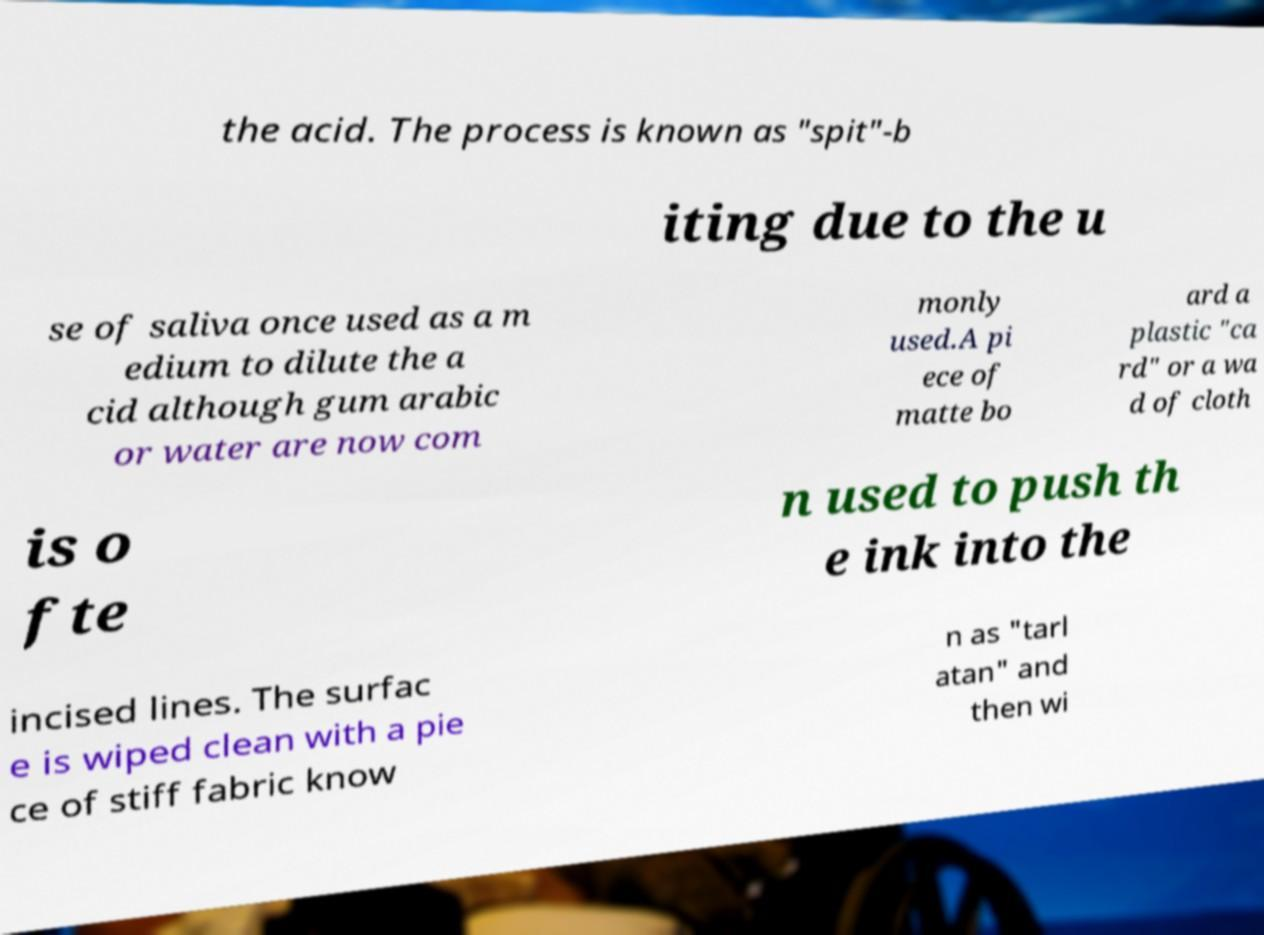Can you accurately transcribe the text from the provided image for me? the acid. The process is known as "spit"-b iting due to the u se of saliva once used as a m edium to dilute the a cid although gum arabic or water are now com monly used.A pi ece of matte bo ard a plastic "ca rd" or a wa d of cloth is o fte n used to push th e ink into the incised lines. The surfac e is wiped clean with a pie ce of stiff fabric know n as "tarl atan" and then wi 